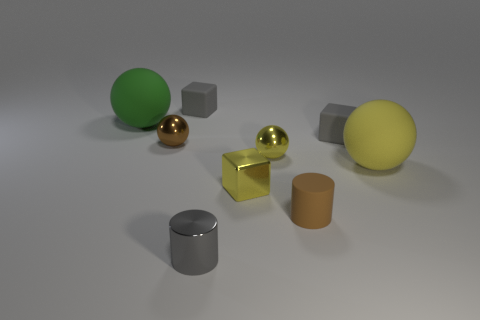Subtract all purple spheres. Subtract all gray blocks. How many spheres are left? 4 Add 1 metal objects. How many objects exist? 10 Subtract all cylinders. How many objects are left? 7 Subtract 1 brown cylinders. How many objects are left? 8 Subtract all large yellow objects. Subtract all small gray shiny things. How many objects are left? 7 Add 2 gray cylinders. How many gray cylinders are left? 3 Add 2 shiny things. How many shiny things exist? 6 